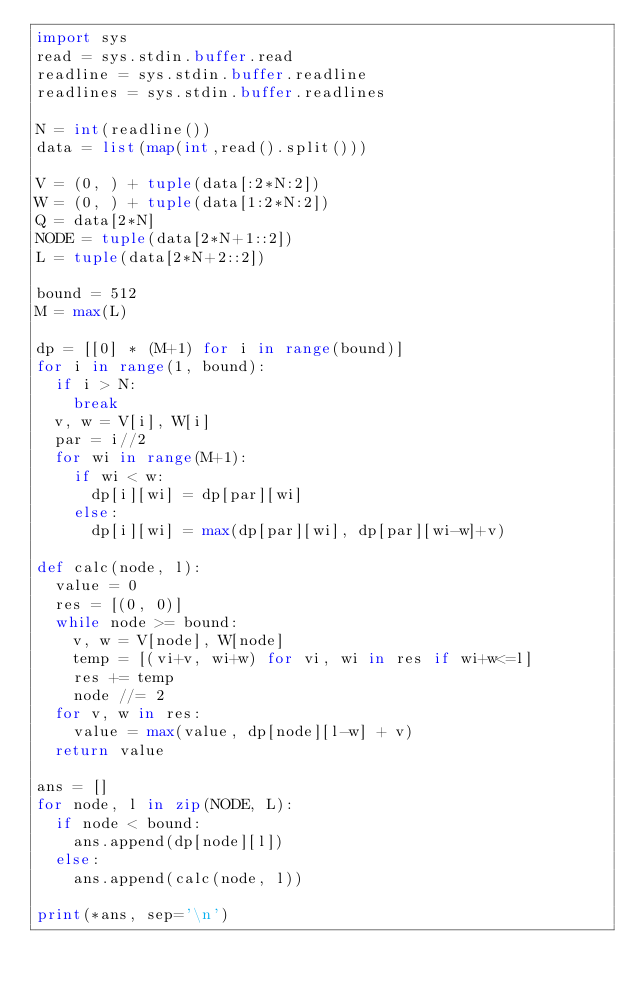Convert code to text. <code><loc_0><loc_0><loc_500><loc_500><_Python_>import sys
read = sys.stdin.buffer.read
readline = sys.stdin.buffer.readline
readlines = sys.stdin.buffer.readlines
 
N = int(readline())
data = list(map(int,read().split()))
 
V = (0, ) + tuple(data[:2*N:2])
W = (0, ) + tuple(data[1:2*N:2])
Q = data[2*N]
NODE = tuple(data[2*N+1::2])
L = tuple(data[2*N+2::2])
 
bound = 512
M = max(L)

dp = [[0] * (M+1) for i in range(bound)]
for i in range(1, bound):
  if i > N:
    break
  v, w = V[i], W[i]
  par = i//2
  for wi in range(M+1):
    if wi < w:
      dp[i][wi] = dp[par][wi]
    else:
      dp[i][wi] = max(dp[par][wi], dp[par][wi-w]+v)

def calc(node, l):
  value = 0
  res = [(0, 0)]
  while node >= bound:
    v, w = V[node], W[node]
    temp = [(vi+v, wi+w) for vi, wi in res if wi+w<=l]
    res += temp
    node //= 2
  for v, w in res:
    value = max(value, dp[node][l-w] + v)
  return value

ans = []
for node, l in zip(NODE, L):
  if node < bound:
    ans.append(dp[node][l])
  else:
    ans.append(calc(node, l))

print(*ans, sep='\n')</code> 